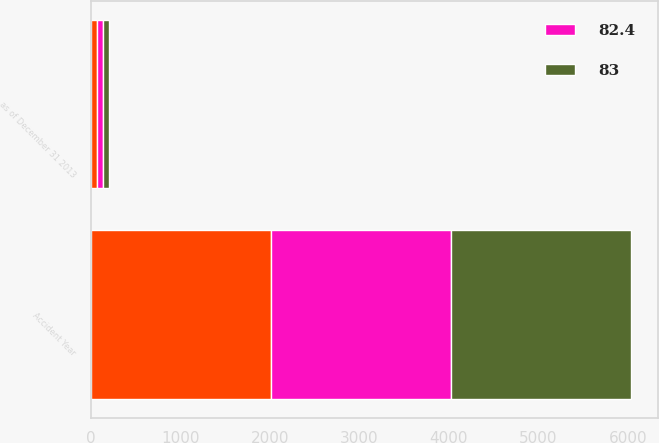Convert chart. <chart><loc_0><loc_0><loc_500><loc_500><stacked_bar_chart><ecel><fcel>Accident Year<fcel>as of December 31 2013<nl><fcel>nan<fcel>2013<fcel>68<nl><fcel>82.4<fcel>2011<fcel>67<nl><fcel>83<fcel>2011<fcel>67<nl></chart> 